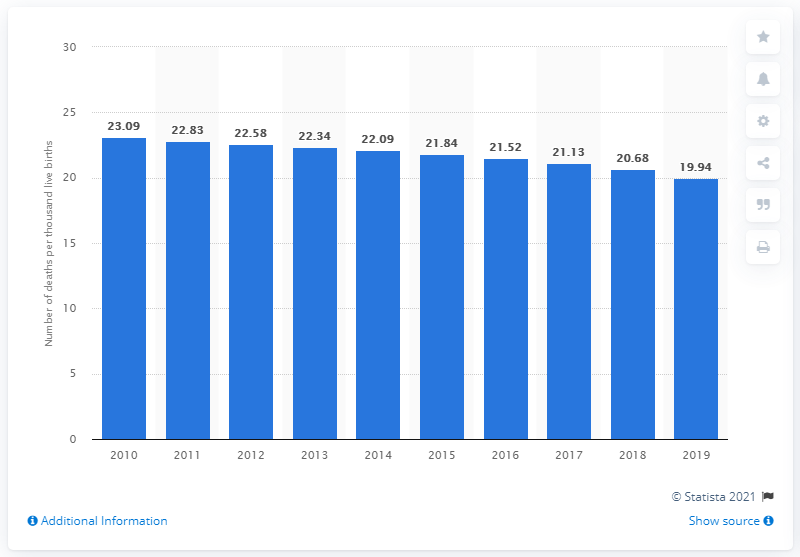Draw attention to some important aspects in this diagram. In 2019, the under-five child mortality rate in Vietnam was 19.94. 